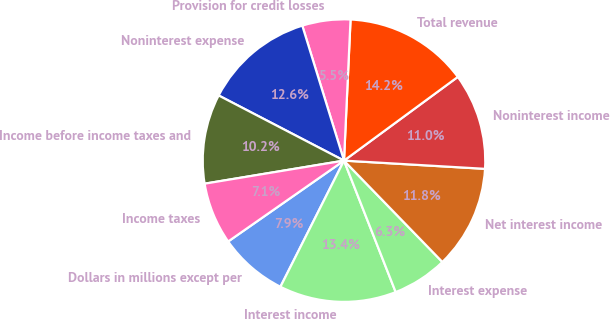Convert chart. <chart><loc_0><loc_0><loc_500><loc_500><pie_chart><fcel>Dollars in millions except per<fcel>Interest income<fcel>Interest expense<fcel>Net interest income<fcel>Noninterest income<fcel>Total revenue<fcel>Provision for credit losses<fcel>Noninterest expense<fcel>Income before income taxes and<fcel>Income taxes<nl><fcel>7.87%<fcel>13.39%<fcel>6.3%<fcel>11.81%<fcel>11.02%<fcel>14.17%<fcel>5.51%<fcel>12.6%<fcel>10.24%<fcel>7.09%<nl></chart> 